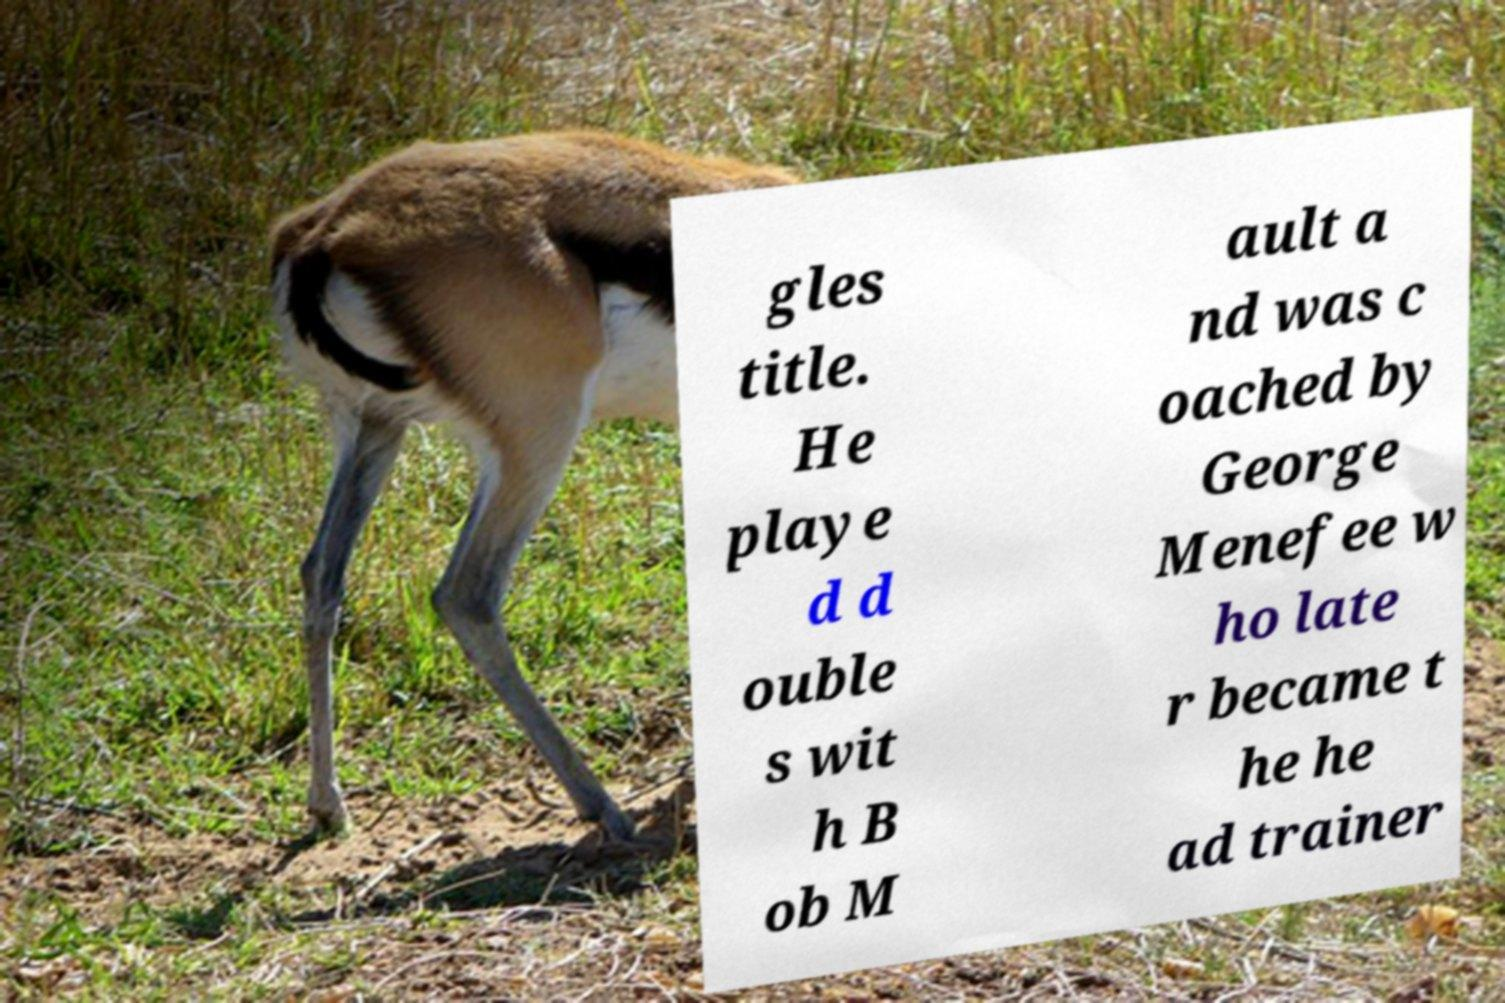For documentation purposes, I need the text within this image transcribed. Could you provide that? gles title. He playe d d ouble s wit h B ob M ault a nd was c oached by George Menefee w ho late r became t he he ad trainer 